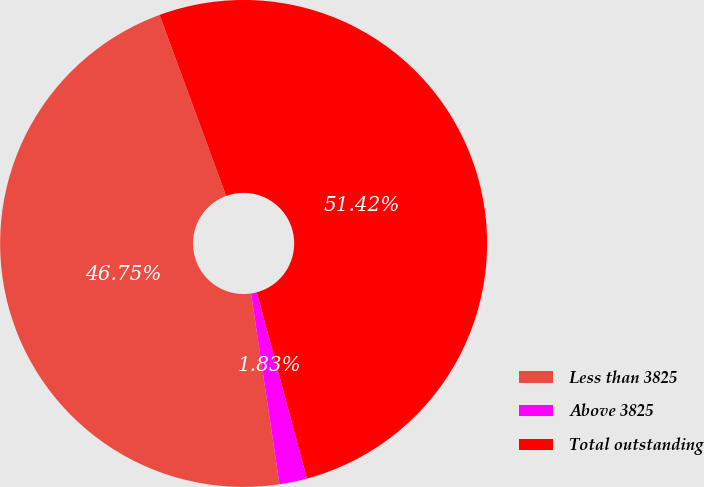Convert chart. <chart><loc_0><loc_0><loc_500><loc_500><pie_chart><fcel>Less than 3825<fcel>Above 3825<fcel>Total outstanding<nl><fcel>46.75%<fcel>1.83%<fcel>51.42%<nl></chart> 